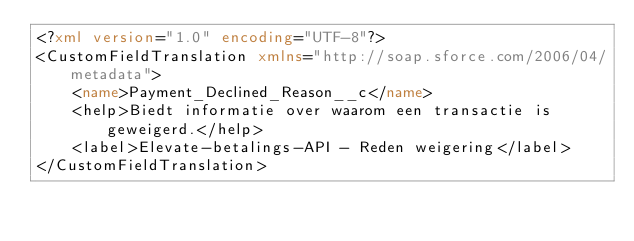Convert code to text. <code><loc_0><loc_0><loc_500><loc_500><_XML_><?xml version="1.0" encoding="UTF-8"?>
<CustomFieldTranslation xmlns="http://soap.sforce.com/2006/04/metadata">
    <name>Payment_Declined_Reason__c</name>
    <help>Biedt informatie over waarom een transactie is geweigerd.</help>
    <label>Elevate-betalings-API - Reden weigering</label>
</CustomFieldTranslation>
</code> 